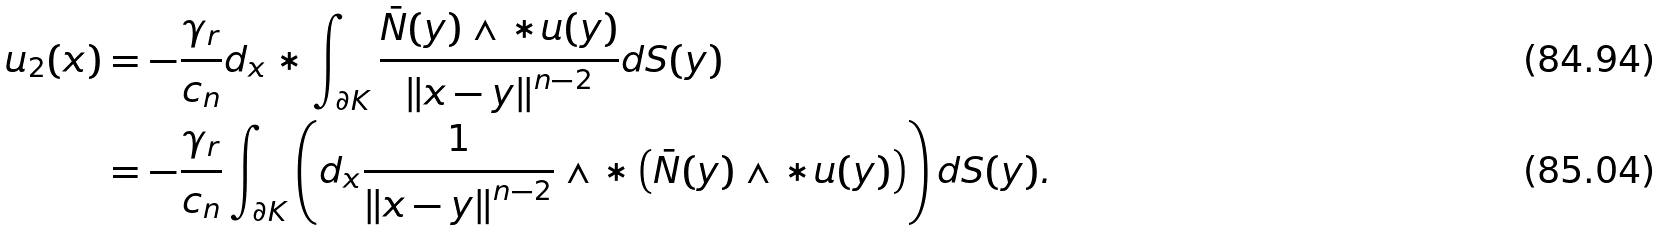<formula> <loc_0><loc_0><loc_500><loc_500>u _ { 2 } ( x ) & = - \frac { \gamma _ { r } } { c _ { n } } d _ { x } \ast \int _ { \partial K } \frac { \bar { N } ( y ) \wedge \ast u ( y ) } { \left \| x - y \right \| ^ { n - 2 } } d S ( y ) \\ & = - \frac { \gamma _ { r } } { c _ { n } } \int _ { \partial K } \left ( d _ { x } \frac { 1 } { \left \| x - y \right \| ^ { n - 2 } } \wedge \ast \left ( \bar { N } ( y ) \wedge \ast u ( y ) \right ) \right ) d S ( y ) .</formula> 